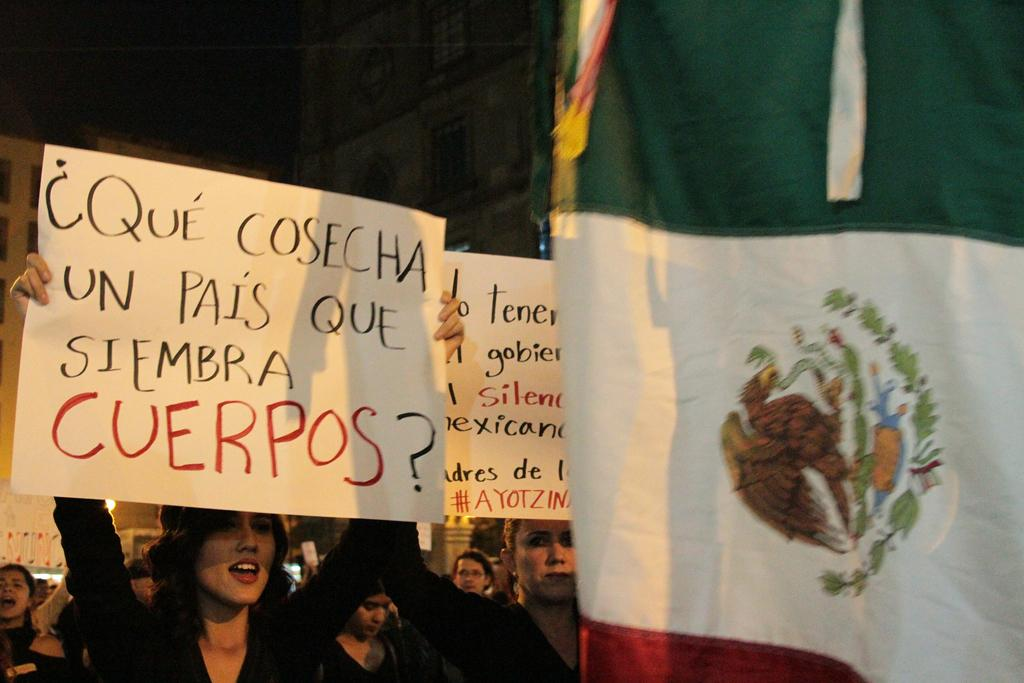How many people are present in the image? There are many people in the image. What are the people holding in the image? The people are holding banners with text on them. What can be seen on the right side of the image? There is a flag on the right side of the image. What is visible in the background of the image? There are buildings in the background of the image. How many beds are visible in the image? There are no beds present in the image. What type of calendar is being used by the fireman in the image? There is no fireman or calendar present in the image. 